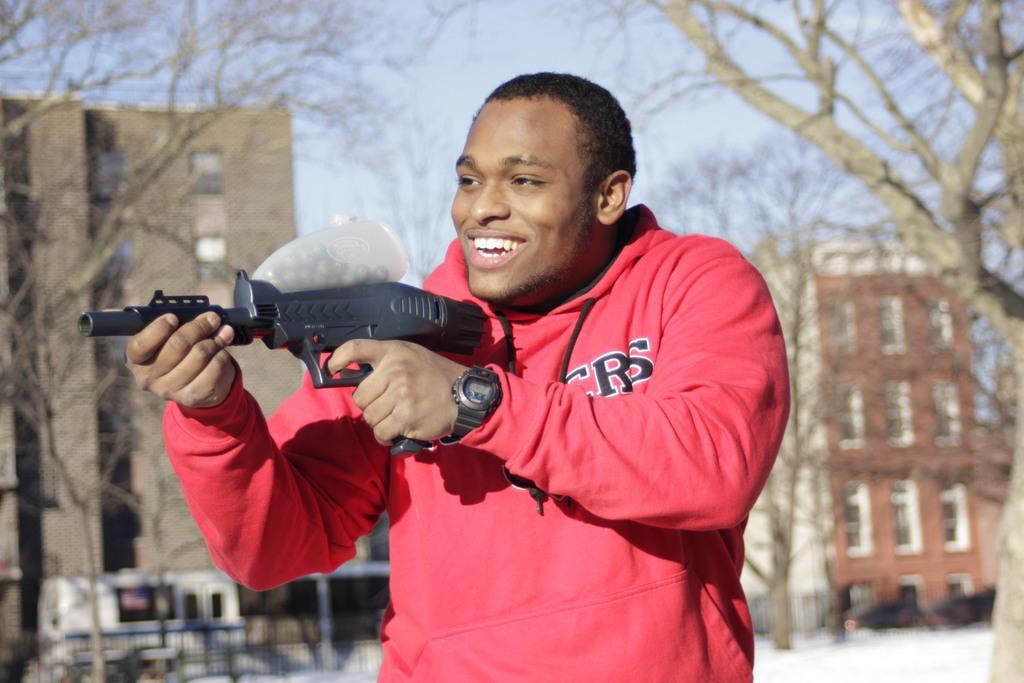Please provide a concise description of this image. In the front of the image a person is smiling and holding a weapon. In the background of the image I can see railing, vehicles, trees, buildings and sky. 